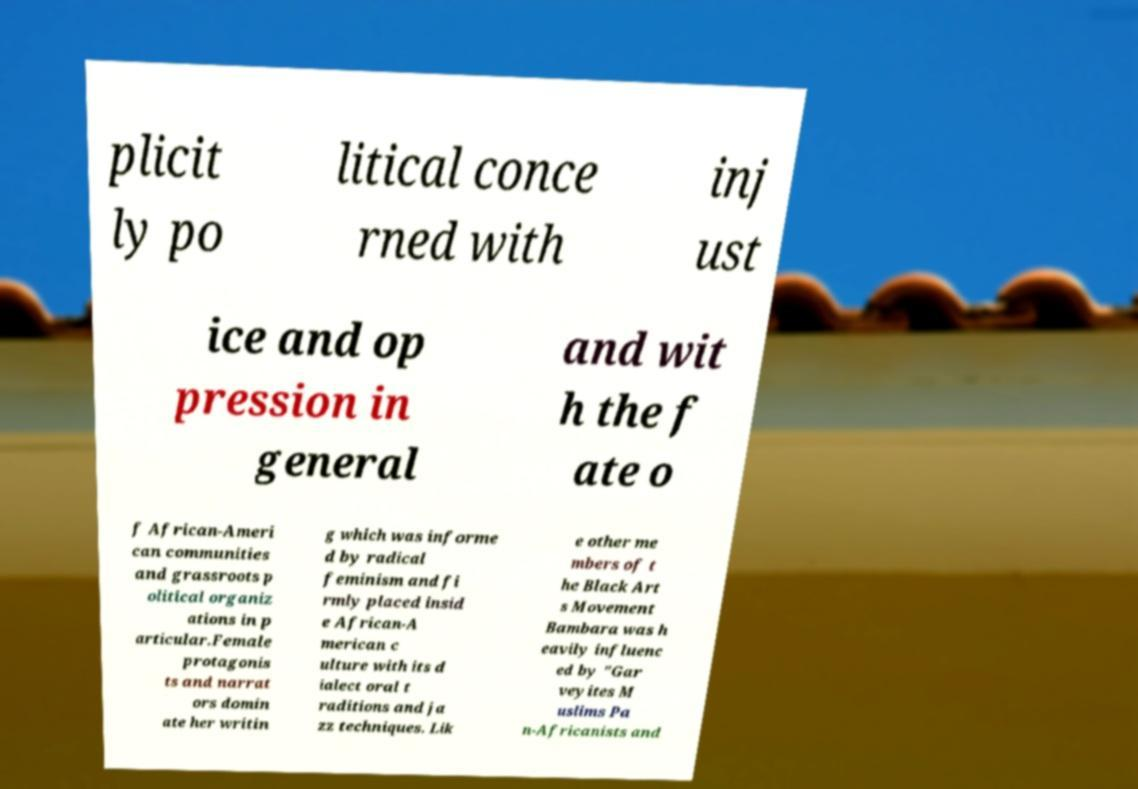Can you accurately transcribe the text from the provided image for me? plicit ly po litical conce rned with inj ust ice and op pression in general and wit h the f ate o f African-Ameri can communities and grassroots p olitical organiz ations in p articular.Female protagonis ts and narrat ors domin ate her writin g which was informe d by radical feminism and fi rmly placed insid e African-A merican c ulture with its d ialect oral t raditions and ja zz techniques. Lik e other me mbers of t he Black Art s Movement Bambara was h eavily influenc ed by "Gar veyites M uslims Pa n-Africanists and 